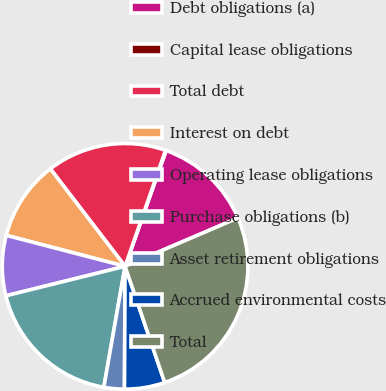Convert chart. <chart><loc_0><loc_0><loc_500><loc_500><pie_chart><fcel>Debt obligations (a)<fcel>Capital lease obligations<fcel>Total debt<fcel>Interest on debt<fcel>Operating lease obligations<fcel>Purchase obligations (b)<fcel>Asset retirement obligations<fcel>Accrued environmental costs<fcel>Total<nl><fcel>13.14%<fcel>0.08%<fcel>15.75%<fcel>10.53%<fcel>7.92%<fcel>18.37%<fcel>2.69%<fcel>5.31%<fcel>26.2%<nl></chart> 